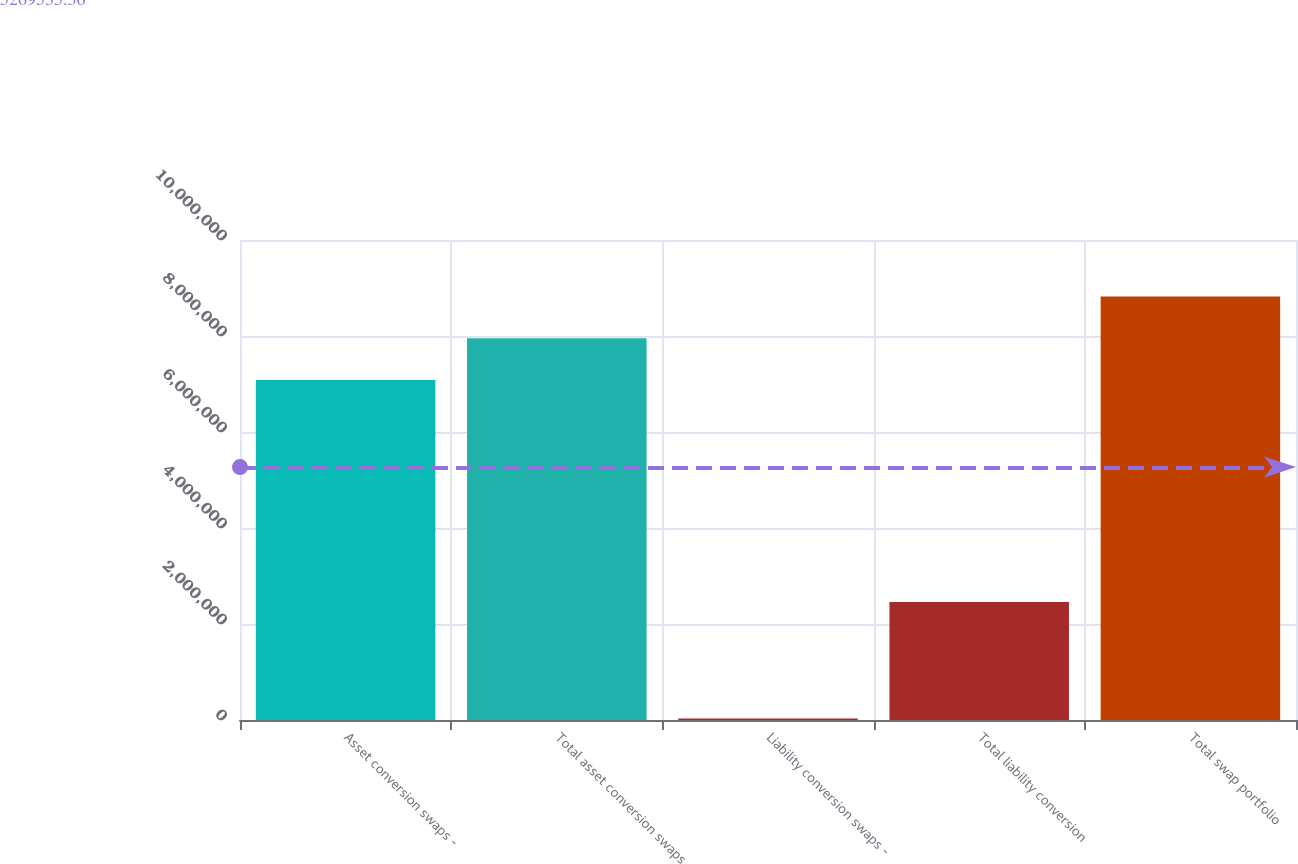Convert chart to OTSL. <chart><loc_0><loc_0><loc_500><loc_500><bar_chart><fcel>Asset conversion swaps -<fcel>Total asset conversion swaps<fcel>Liability conversion swaps -<fcel>Total liability conversion<fcel>Total swap portfolio<nl><fcel>7.085e+06<fcel>7.95269e+06<fcel>30000<fcel>2.4596e+06<fcel>8.82038e+06<nl></chart> 